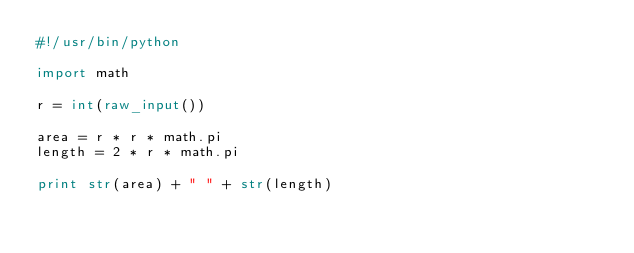Convert code to text. <code><loc_0><loc_0><loc_500><loc_500><_Python_>#!/usr/bin/python

import math

r = int(raw_input())

area = r * r * math.pi
length = 2 * r * math.pi

print str(area) + " " + str(length)</code> 